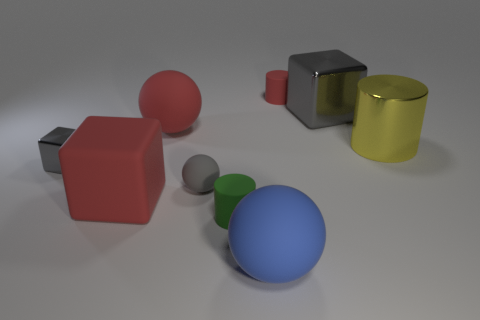Add 1 small purple cylinders. How many objects exist? 10 Subtract all balls. How many objects are left? 6 Subtract 1 blue spheres. How many objects are left? 8 Subtract all large cyan rubber balls. Subtract all large metal cylinders. How many objects are left? 8 Add 2 red spheres. How many red spheres are left? 3 Add 5 small gray matte objects. How many small gray matte objects exist? 6 